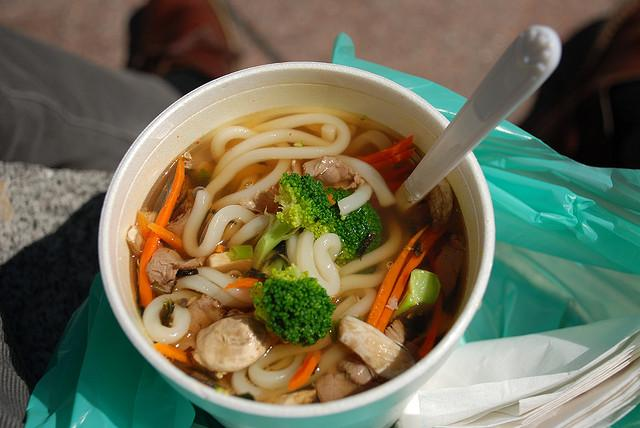What country do the noodles originate from?

Choices:
A) ukraine
B) korea
C) japan
D) china china 